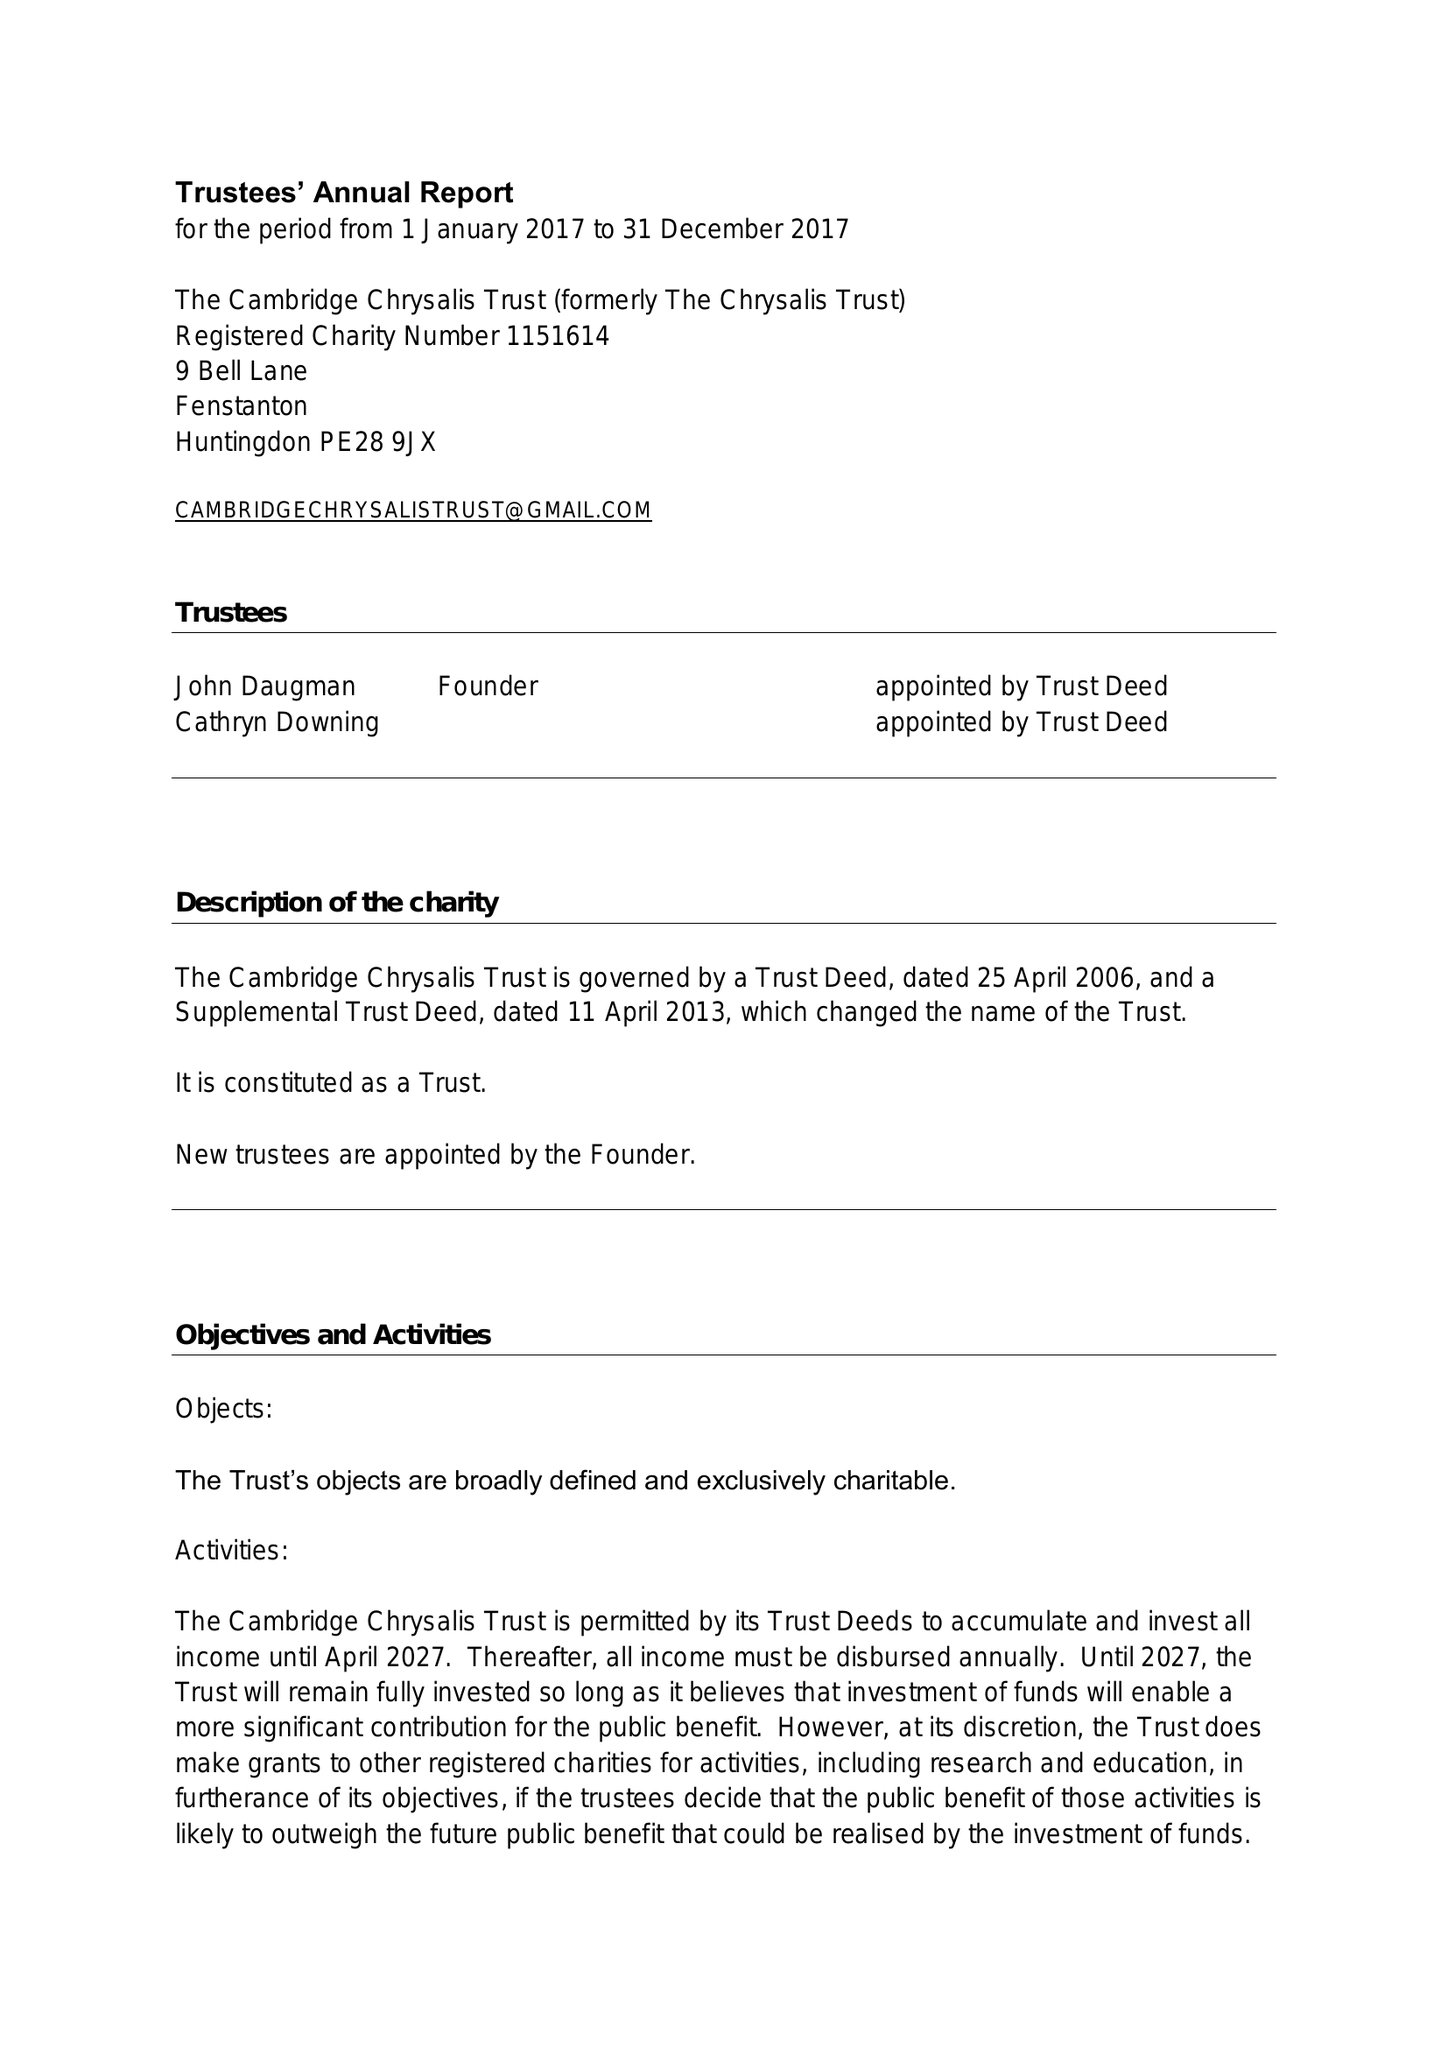What is the value for the address__postcode?
Answer the question using a single word or phrase. PE28 9JX 